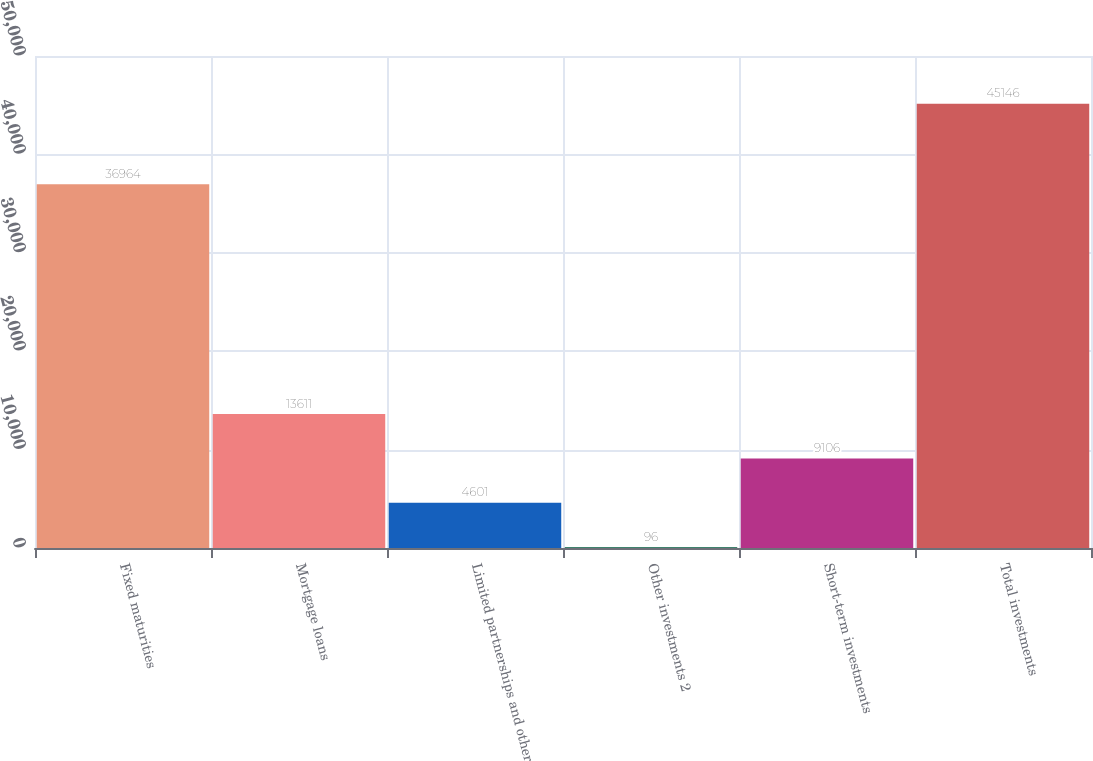<chart> <loc_0><loc_0><loc_500><loc_500><bar_chart><fcel>Fixed maturities<fcel>Mortgage loans<fcel>Limited partnerships and other<fcel>Other investments 2<fcel>Short-term investments<fcel>Total investments<nl><fcel>36964<fcel>13611<fcel>4601<fcel>96<fcel>9106<fcel>45146<nl></chart> 